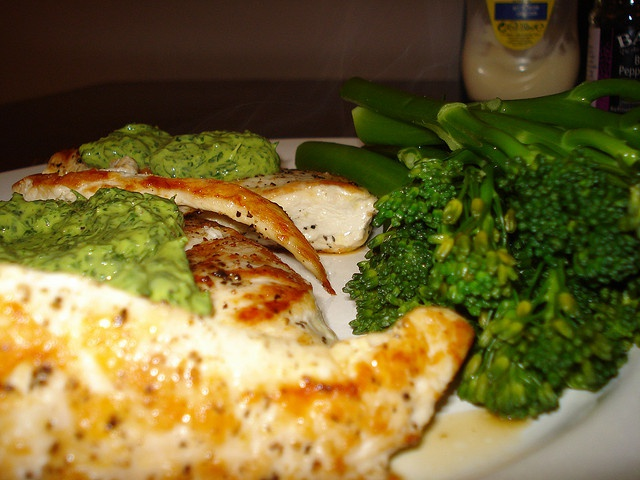Describe the objects in this image and their specific colors. I can see pizza in black, khaki, orange, tan, and beige tones, broccoli in black, darkgreen, and olive tones, bottle in black, olive, maroon, and gray tones, and bottle in black, maroon, and gray tones in this image. 